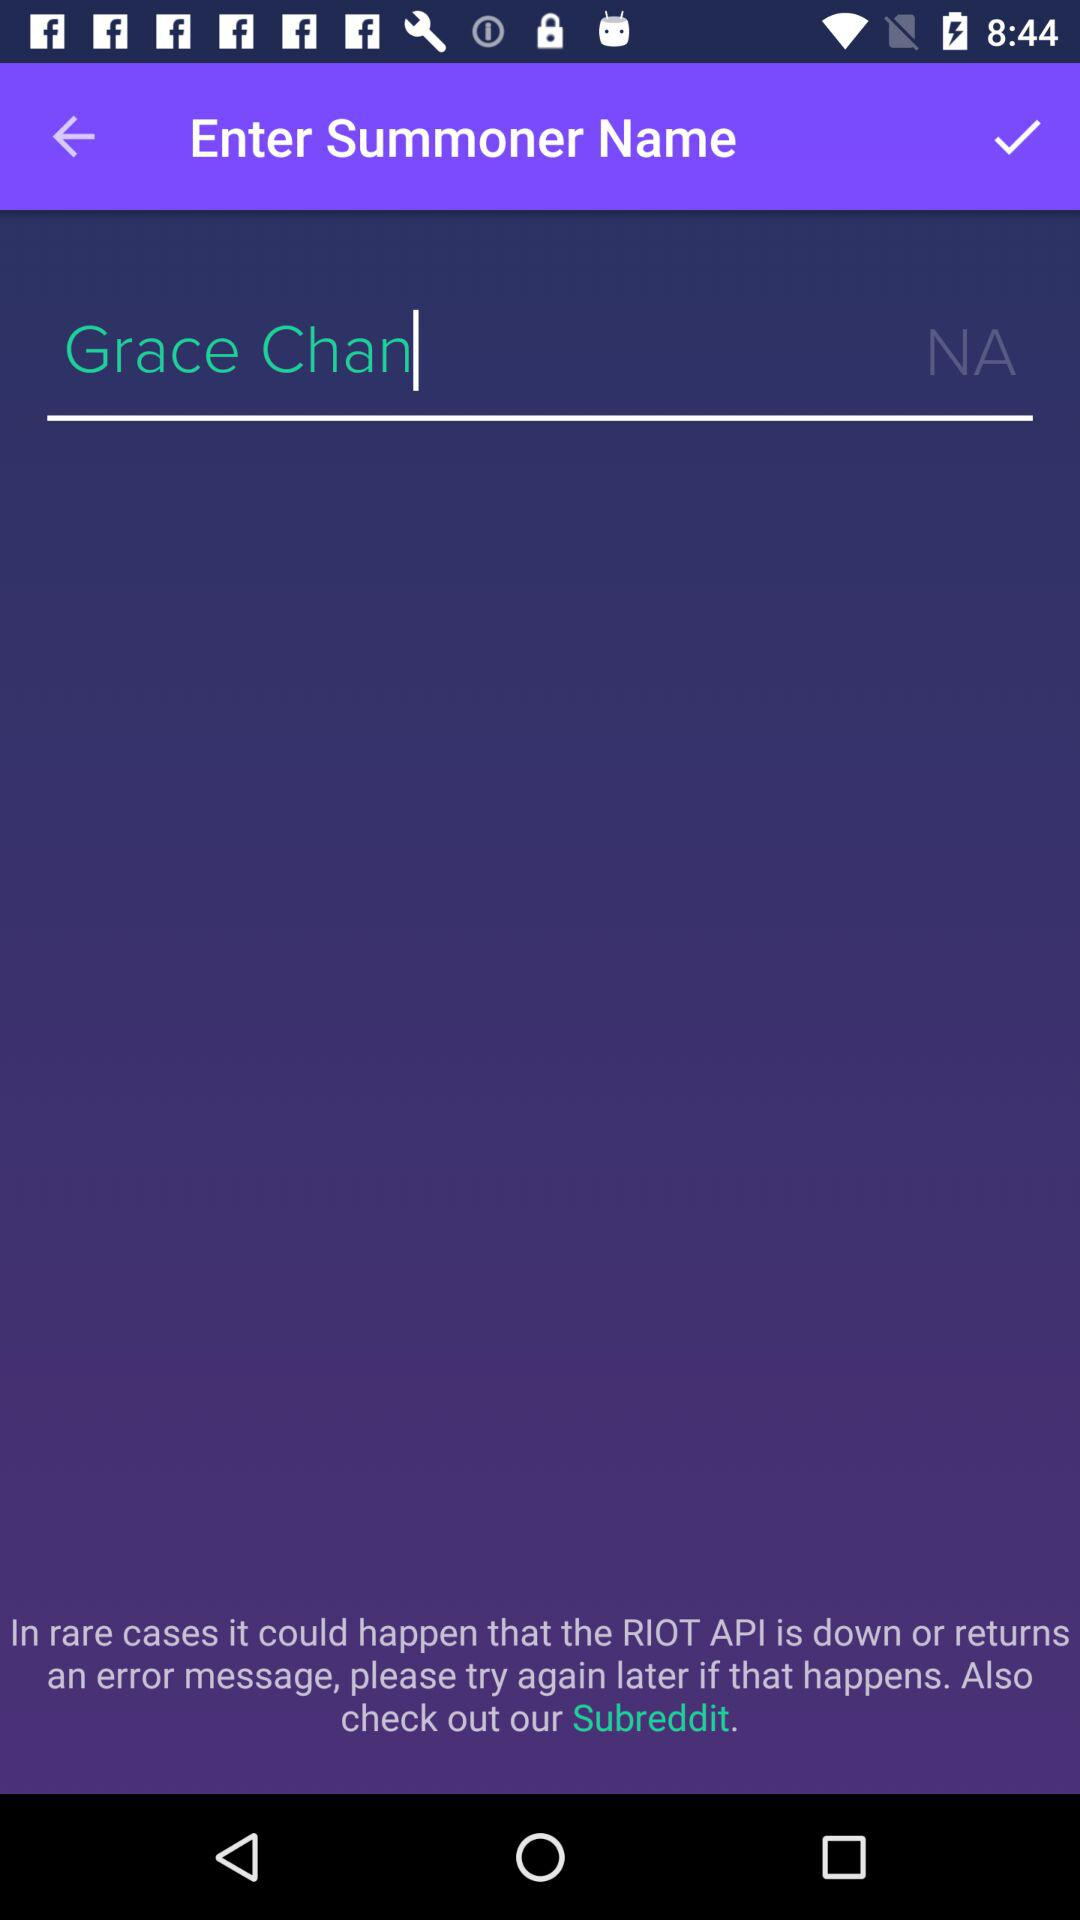How many skill points does "Summoner" Grace Chan have?
When the provided information is insufficient, respond with <no answer>. <no answer> 